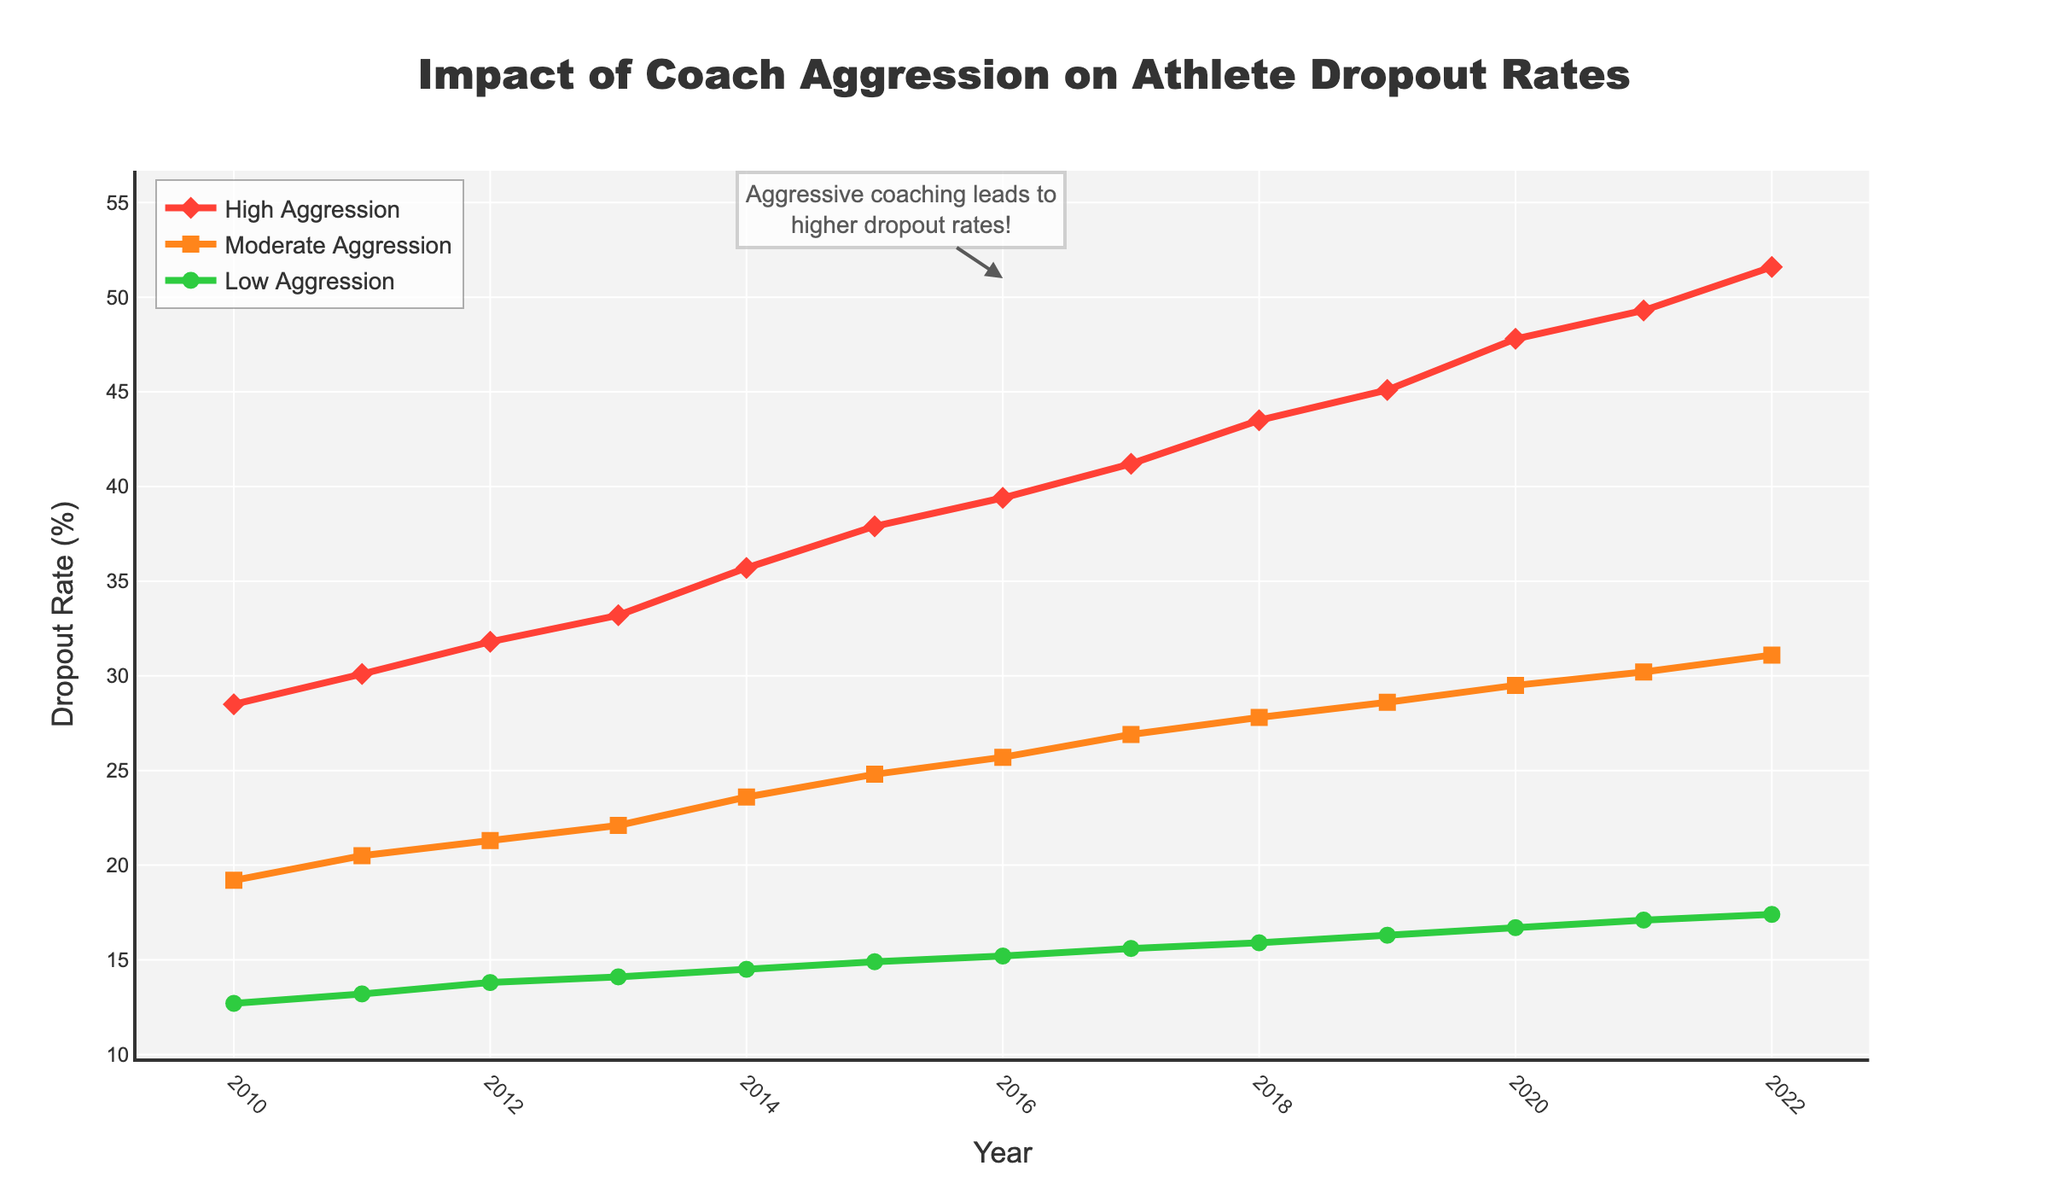What general trend do you observe over time for the High Aggression Dropout %? Observing the trend for the High Aggression Dropout %, the dropout rate continuously increases year by year from 28.5% in 2010 to 51.6% in 2022.
Answer: It increases How does the Moderate Aggression Dropout % in 2014 compare to that in 2021? In 2014, the Moderate Aggression Dropout % is 23.6%, and in 2021, it is 30.2%. The dropout rate increases from 2014 to 2021.
Answer: It increases Which year shows the biggest difference between High Aggression Dropout % and Low Aggression Dropout %? By comparing the differences, 2022 shows the biggest difference: High Aggression Dropout % is 51.6%, and Low Aggression Dropout % is 17.4%, giving a difference of 34.2%.
Answer: 2022 Calculate the average Low Aggression Dropout % over the years 2010 to 2015. The Low Aggression Dropout % values from 2010 to 2015 are 12.7, 13.2, 13.8, 14.1, 14.5, and 14.9. Summing these gives 83.2. Dividing by 6 years, the average is 83.2 / 6 = 13.87%.
Answer: 13.87% Which trend line has the steepest upward slope? By comparing the slopes, the High Aggression Dropout % line has the steepest upward slope as it shows the largest increase over years.
Answer: High Aggression What is the difference in dropout rates between High Aggression and Moderate Aggression in 2016? In 2016, the High Aggression Dropout % is 39.4% and the Moderate Aggression Dropout % is 25.7%. The difference is 39.4% - 25.7% = 13.7%.
Answer: 13.7% In which years does the Low Aggression Dropout % show the smallest increase from the previous year? By observing year-to-year changes, the smallest increase occurs from 2012 to 2013, where it increases from 13.8% to 14.1%, a difference of 0.3%.
Answer: 2012 to 2013 How much has the Moderate Aggression Dropout % increased from 2010 to 2022? In 2010, the Moderate Aggression Dropout % is 19.2%, and in 2022 it is 31.1%. The increase is 31.1% - 19.2% = 11.9%.
Answer: 11.9% Which aggression level's dropout rate surpassed 40% first, and in which year? The High Aggression Dropout % surpassed 40% first in the year 2017 with a rate of 41.2%.
Answer: High Aggression, 2017 